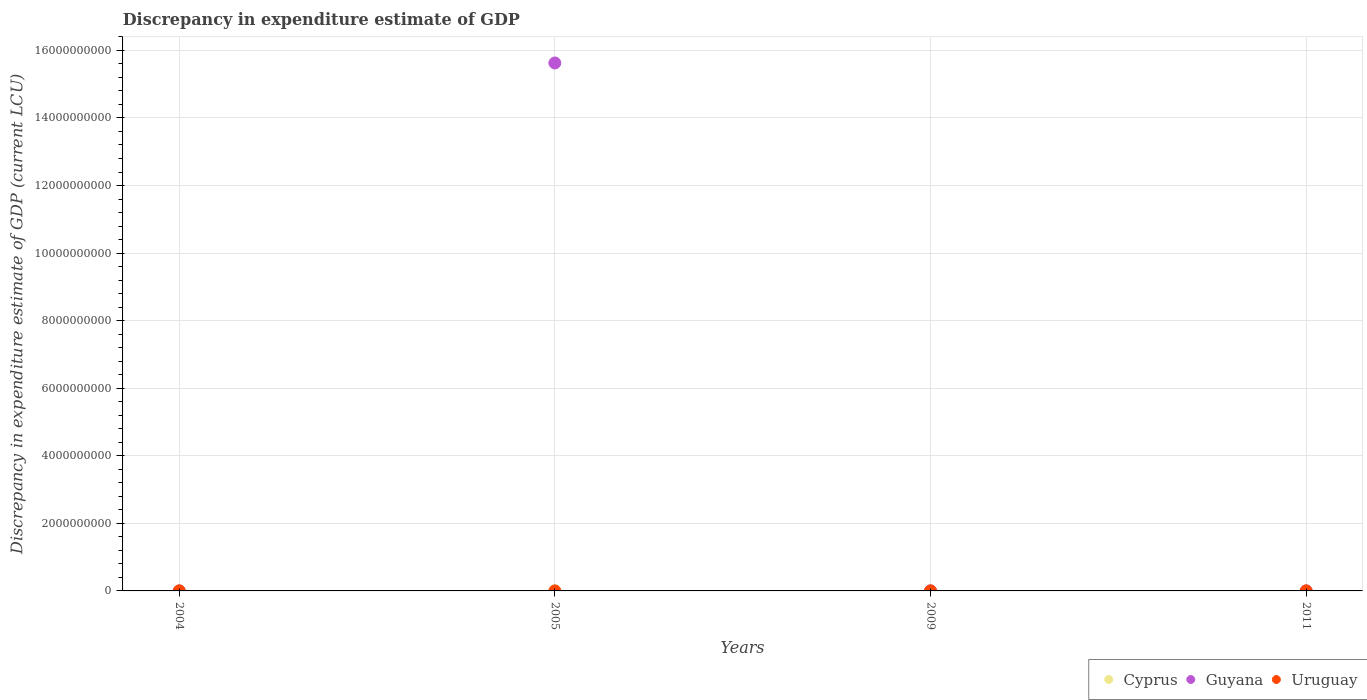How many different coloured dotlines are there?
Provide a succinct answer. 3. Across all years, what is the maximum discrepancy in expenditure estimate of GDP in Cyprus?
Offer a very short reply. 10000. Across all years, what is the minimum discrepancy in expenditure estimate of GDP in Cyprus?
Your response must be concise. 0. What is the total discrepancy in expenditure estimate of GDP in Guyana in the graph?
Your answer should be very brief. 1.56e+1. What is the difference between the discrepancy in expenditure estimate of GDP in Cyprus in 2004 and that in 2009?
Your answer should be very brief. 0. What is the average discrepancy in expenditure estimate of GDP in Guyana per year?
Your response must be concise. 3.91e+09. In the year 2009, what is the difference between the discrepancy in expenditure estimate of GDP in Guyana and discrepancy in expenditure estimate of GDP in Cyprus?
Provide a short and direct response. 9.90e+05. In how many years, is the discrepancy in expenditure estimate of GDP in Uruguay greater than 1600000000 LCU?
Ensure brevity in your answer.  0. What is the ratio of the discrepancy in expenditure estimate of GDP in Guyana in 2004 to that in 2005?
Make the answer very short. 5.119113633278497e-7. Is the discrepancy in expenditure estimate of GDP in Cyprus in 2005 less than that in 2009?
Make the answer very short. No. Is the difference between the discrepancy in expenditure estimate of GDP in Guyana in 2005 and 2009 greater than the difference between the discrepancy in expenditure estimate of GDP in Cyprus in 2005 and 2009?
Your answer should be very brief. Yes. What is the difference between the highest and the lowest discrepancy in expenditure estimate of GDP in Uruguay?
Your response must be concise. 100. Is the sum of the discrepancy in expenditure estimate of GDP in Cyprus in 2004 and 2009 greater than the maximum discrepancy in expenditure estimate of GDP in Guyana across all years?
Offer a very short reply. No. Is the discrepancy in expenditure estimate of GDP in Guyana strictly greater than the discrepancy in expenditure estimate of GDP in Uruguay over the years?
Provide a short and direct response. No. What is the difference between two consecutive major ticks on the Y-axis?
Your answer should be very brief. 2.00e+09. Does the graph contain any zero values?
Provide a succinct answer. Yes. Where does the legend appear in the graph?
Offer a terse response. Bottom right. What is the title of the graph?
Your answer should be very brief. Discrepancy in expenditure estimate of GDP. Does "Greenland" appear as one of the legend labels in the graph?
Offer a very short reply. No. What is the label or title of the X-axis?
Give a very brief answer. Years. What is the label or title of the Y-axis?
Keep it short and to the point. Discrepancy in expenditure estimate of GDP (current LCU). What is the Discrepancy in expenditure estimate of GDP (current LCU) of Guyana in 2004?
Provide a short and direct response. 8000. What is the Discrepancy in expenditure estimate of GDP (current LCU) of Uruguay in 2004?
Make the answer very short. 0. What is the Discrepancy in expenditure estimate of GDP (current LCU) in Guyana in 2005?
Provide a succinct answer. 1.56e+1. What is the Discrepancy in expenditure estimate of GDP (current LCU) in Cyprus in 2009?
Provide a succinct answer. 10000. What is the Discrepancy in expenditure estimate of GDP (current LCU) of Guyana in 2009?
Your answer should be very brief. 1.00e+06. What is the Discrepancy in expenditure estimate of GDP (current LCU) of Uruguay in 2009?
Your answer should be compact. 0. What is the Discrepancy in expenditure estimate of GDP (current LCU) of Guyana in 2011?
Make the answer very short. 0. What is the Discrepancy in expenditure estimate of GDP (current LCU) in Uruguay in 2011?
Provide a short and direct response. 100. Across all years, what is the maximum Discrepancy in expenditure estimate of GDP (current LCU) of Cyprus?
Give a very brief answer. 10000. Across all years, what is the maximum Discrepancy in expenditure estimate of GDP (current LCU) of Guyana?
Your answer should be compact. 1.56e+1. Across all years, what is the maximum Discrepancy in expenditure estimate of GDP (current LCU) in Uruguay?
Keep it short and to the point. 100. Across all years, what is the minimum Discrepancy in expenditure estimate of GDP (current LCU) of Guyana?
Your response must be concise. 0. Across all years, what is the minimum Discrepancy in expenditure estimate of GDP (current LCU) of Uruguay?
Your answer should be compact. 0. What is the total Discrepancy in expenditure estimate of GDP (current LCU) of Cyprus in the graph?
Your answer should be compact. 3.00e+04. What is the total Discrepancy in expenditure estimate of GDP (current LCU) of Guyana in the graph?
Keep it short and to the point. 1.56e+1. What is the total Discrepancy in expenditure estimate of GDP (current LCU) in Uruguay in the graph?
Your response must be concise. 100. What is the difference between the Discrepancy in expenditure estimate of GDP (current LCU) in Cyprus in 2004 and that in 2005?
Give a very brief answer. 0. What is the difference between the Discrepancy in expenditure estimate of GDP (current LCU) of Guyana in 2004 and that in 2005?
Offer a terse response. -1.56e+1. What is the difference between the Discrepancy in expenditure estimate of GDP (current LCU) of Cyprus in 2004 and that in 2009?
Make the answer very short. 0. What is the difference between the Discrepancy in expenditure estimate of GDP (current LCU) in Guyana in 2004 and that in 2009?
Ensure brevity in your answer.  -9.92e+05. What is the difference between the Discrepancy in expenditure estimate of GDP (current LCU) of Guyana in 2005 and that in 2009?
Your answer should be very brief. 1.56e+1. What is the difference between the Discrepancy in expenditure estimate of GDP (current LCU) of Cyprus in 2004 and the Discrepancy in expenditure estimate of GDP (current LCU) of Guyana in 2005?
Make the answer very short. -1.56e+1. What is the difference between the Discrepancy in expenditure estimate of GDP (current LCU) of Cyprus in 2004 and the Discrepancy in expenditure estimate of GDP (current LCU) of Guyana in 2009?
Provide a short and direct response. -9.90e+05. What is the difference between the Discrepancy in expenditure estimate of GDP (current LCU) of Cyprus in 2004 and the Discrepancy in expenditure estimate of GDP (current LCU) of Uruguay in 2011?
Offer a very short reply. 9900. What is the difference between the Discrepancy in expenditure estimate of GDP (current LCU) in Guyana in 2004 and the Discrepancy in expenditure estimate of GDP (current LCU) in Uruguay in 2011?
Your answer should be very brief. 7900. What is the difference between the Discrepancy in expenditure estimate of GDP (current LCU) of Cyprus in 2005 and the Discrepancy in expenditure estimate of GDP (current LCU) of Guyana in 2009?
Offer a terse response. -9.90e+05. What is the difference between the Discrepancy in expenditure estimate of GDP (current LCU) of Cyprus in 2005 and the Discrepancy in expenditure estimate of GDP (current LCU) of Uruguay in 2011?
Make the answer very short. 9900. What is the difference between the Discrepancy in expenditure estimate of GDP (current LCU) in Guyana in 2005 and the Discrepancy in expenditure estimate of GDP (current LCU) in Uruguay in 2011?
Your answer should be compact. 1.56e+1. What is the difference between the Discrepancy in expenditure estimate of GDP (current LCU) of Cyprus in 2009 and the Discrepancy in expenditure estimate of GDP (current LCU) of Uruguay in 2011?
Give a very brief answer. 9900. What is the difference between the Discrepancy in expenditure estimate of GDP (current LCU) in Guyana in 2009 and the Discrepancy in expenditure estimate of GDP (current LCU) in Uruguay in 2011?
Make the answer very short. 1.00e+06. What is the average Discrepancy in expenditure estimate of GDP (current LCU) in Cyprus per year?
Keep it short and to the point. 7500. What is the average Discrepancy in expenditure estimate of GDP (current LCU) in Guyana per year?
Ensure brevity in your answer.  3.91e+09. In the year 2004, what is the difference between the Discrepancy in expenditure estimate of GDP (current LCU) in Cyprus and Discrepancy in expenditure estimate of GDP (current LCU) in Guyana?
Offer a very short reply. 2000. In the year 2005, what is the difference between the Discrepancy in expenditure estimate of GDP (current LCU) of Cyprus and Discrepancy in expenditure estimate of GDP (current LCU) of Guyana?
Provide a succinct answer. -1.56e+1. In the year 2009, what is the difference between the Discrepancy in expenditure estimate of GDP (current LCU) of Cyprus and Discrepancy in expenditure estimate of GDP (current LCU) of Guyana?
Your answer should be compact. -9.90e+05. What is the ratio of the Discrepancy in expenditure estimate of GDP (current LCU) in Cyprus in 2004 to that in 2009?
Provide a succinct answer. 1. What is the ratio of the Discrepancy in expenditure estimate of GDP (current LCU) in Guyana in 2004 to that in 2009?
Give a very brief answer. 0.01. What is the ratio of the Discrepancy in expenditure estimate of GDP (current LCU) of Cyprus in 2005 to that in 2009?
Your response must be concise. 1. What is the ratio of the Discrepancy in expenditure estimate of GDP (current LCU) in Guyana in 2005 to that in 2009?
Your answer should be very brief. 1.56e+04. What is the difference between the highest and the second highest Discrepancy in expenditure estimate of GDP (current LCU) in Cyprus?
Provide a succinct answer. 0. What is the difference between the highest and the second highest Discrepancy in expenditure estimate of GDP (current LCU) in Guyana?
Your response must be concise. 1.56e+1. What is the difference between the highest and the lowest Discrepancy in expenditure estimate of GDP (current LCU) of Cyprus?
Make the answer very short. 10000. What is the difference between the highest and the lowest Discrepancy in expenditure estimate of GDP (current LCU) of Guyana?
Give a very brief answer. 1.56e+1. What is the difference between the highest and the lowest Discrepancy in expenditure estimate of GDP (current LCU) of Uruguay?
Offer a terse response. 100. 